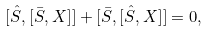<formula> <loc_0><loc_0><loc_500><loc_500>[ \hat { S } , [ \bar { S } , X ] ] + [ \bar { S } , [ \hat { S } , X ] ] = 0 ,</formula> 